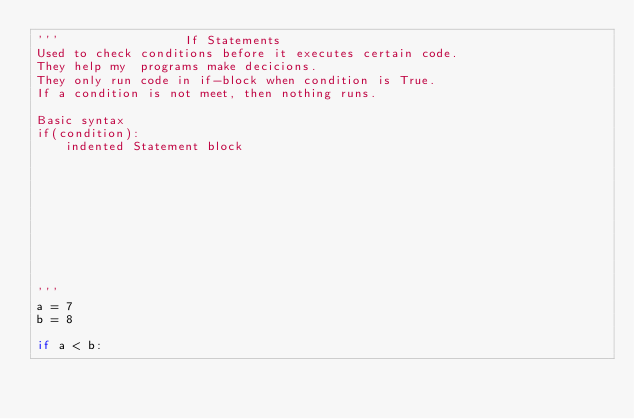Convert code to text. <code><loc_0><loc_0><loc_500><loc_500><_Python_>'''                 If Statements
Used to check conditions before it executes certain code.
They help my  programs make decicions.
They only run code in if-block when condition is True.
If a condition is not meet, then nothing runs.

Basic syntax
if(condition):
    indented Statement block










'''
a = 7
b = 8

if a < b:
    
</code> 